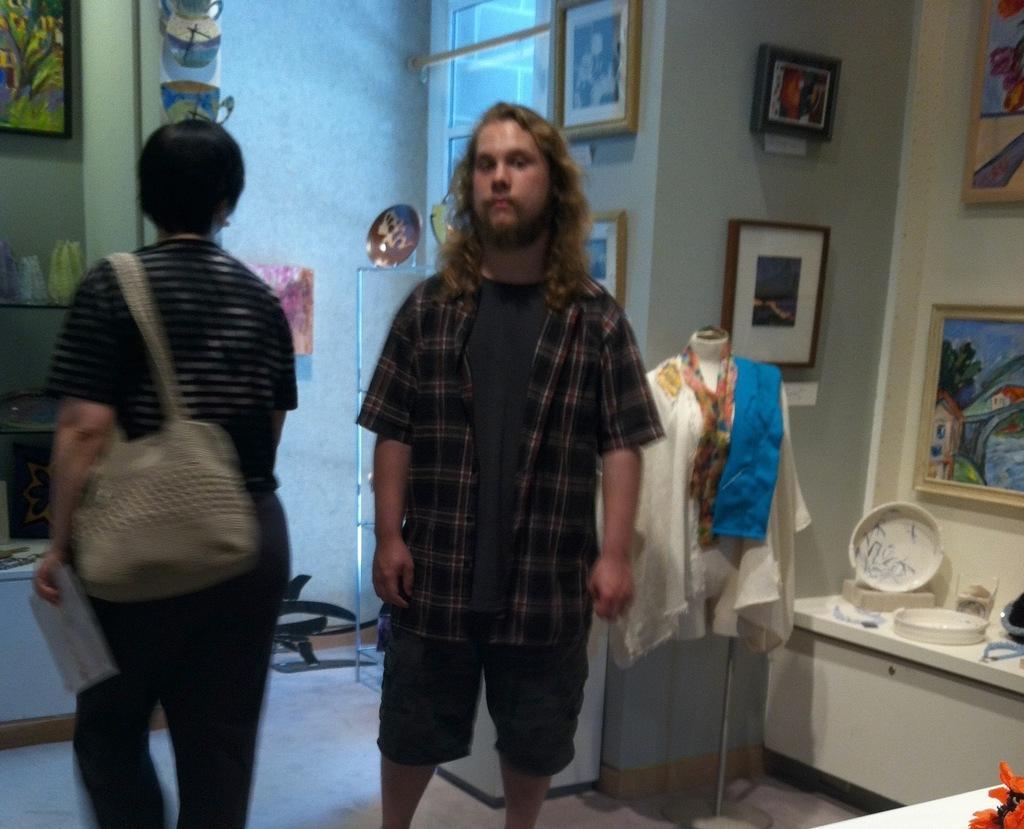Please provide a concise description of this image. In the image there is a man in checkered shirt and shorts standing in the front and there is another person walking on the left side, on the right side there is a mannequin in front of the wall with photographs on it and beside it there is a table with plate and utensils on it and over the back there is window on the wall. 